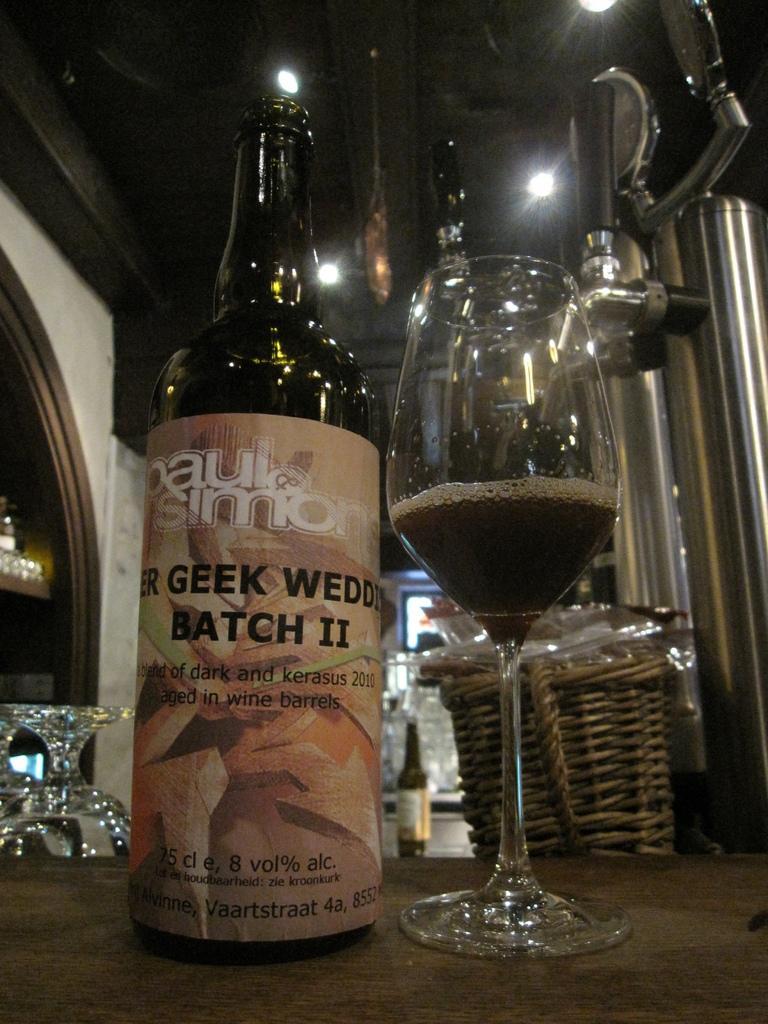Please provide a concise description of this image. This is the picture of a table on which there is a glass, bottle and behind there are some other things and also we can see some lights to the roof. 